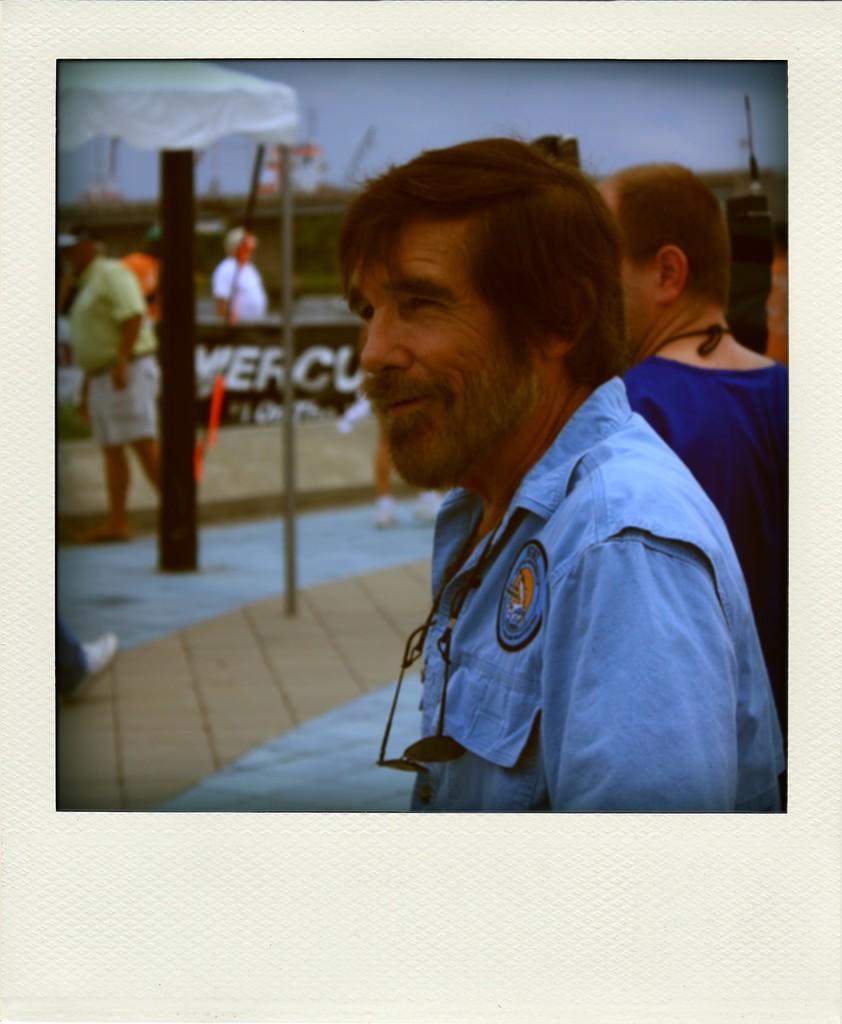Can you describe this image briefly? On the left side of the image we can see a person is standing and a board is there. On the right side of the image we can see a person wearing blue color dress and having spects. 